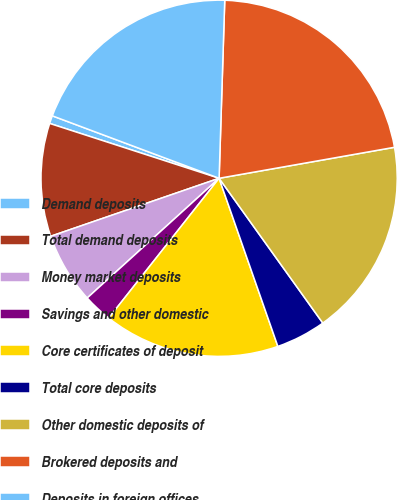Convert chart. <chart><loc_0><loc_0><loc_500><loc_500><pie_chart><fcel>Demand deposits<fcel>Total demand deposits<fcel>Money market deposits<fcel>Savings and other domestic<fcel>Core certificates of deposit<fcel>Total core deposits<fcel>Other domestic deposits of<fcel>Brokered deposits and<fcel>Deposits in foreign offices<nl><fcel>0.72%<fcel>10.26%<fcel>6.45%<fcel>2.63%<fcel>15.99%<fcel>4.54%<fcel>17.89%<fcel>21.71%<fcel>19.8%<nl></chart> 